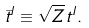<formula> <loc_0><loc_0><loc_500><loc_500>\bar { t } ^ { I } \equiv \sqrt { Z } \, t ^ { I } .</formula> 